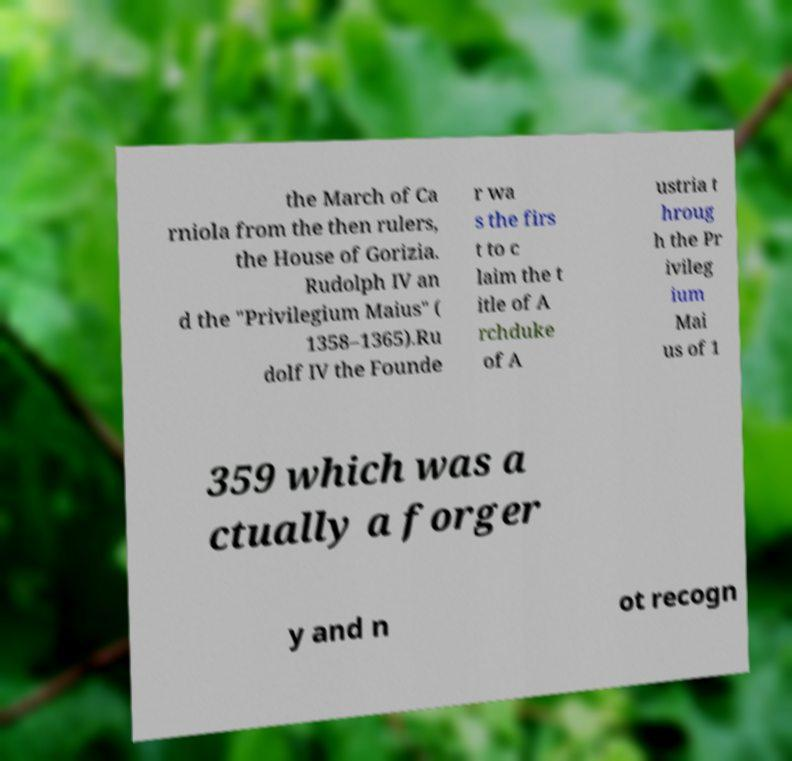For documentation purposes, I need the text within this image transcribed. Could you provide that? the March of Ca rniola from the then rulers, the House of Gorizia. Rudolph IV an d the "Privilegium Maius" ( 1358–1365).Ru dolf IV the Founde r wa s the firs t to c laim the t itle of A rchduke of A ustria t hroug h the Pr ivileg ium Mai us of 1 359 which was a ctually a forger y and n ot recogn 